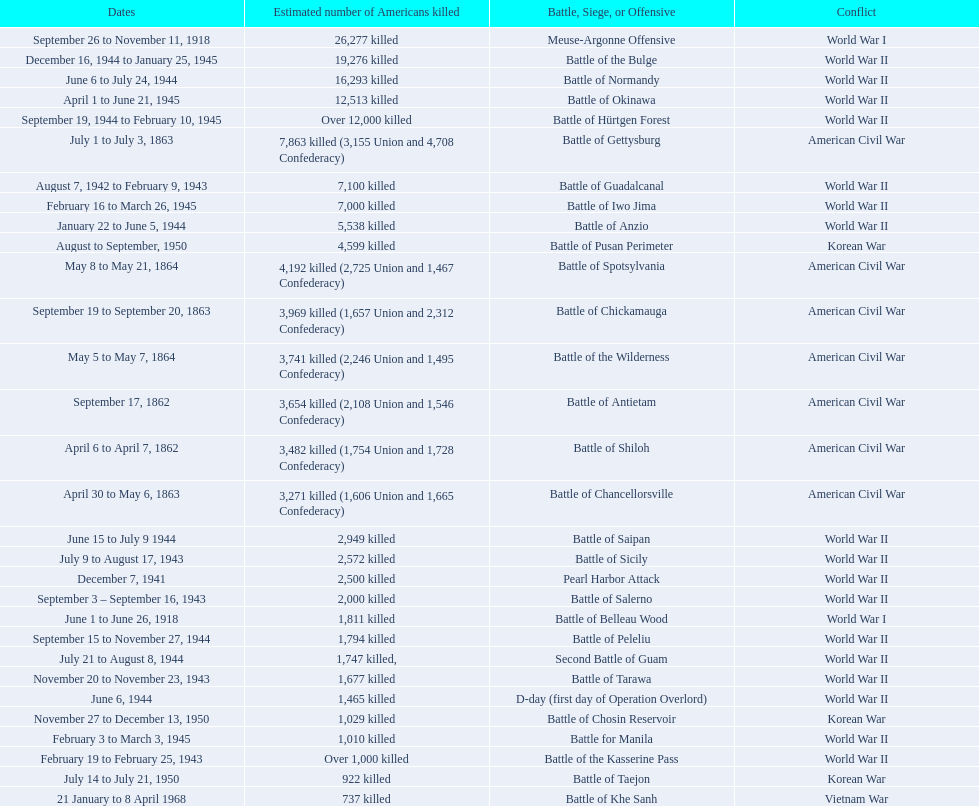How many battles resulted between 3,000 and 4,200 estimated americans killed? 6. Write the full table. {'header': ['Dates', 'Estimated number of Americans killed', 'Battle, Siege, or Offensive', 'Conflict'], 'rows': [['September 26 to November 11, 1918', '26,277 killed', 'Meuse-Argonne Offensive', 'World War I'], ['December 16, 1944 to January 25, 1945', '19,276 killed', 'Battle of the Bulge', 'World War II'], ['June 6 to July 24, 1944', '16,293 killed', 'Battle of Normandy', 'World War II'], ['April 1 to June 21, 1945', '12,513 killed', 'Battle of Okinawa', 'World War II'], ['September 19, 1944 to February 10, 1945', 'Over 12,000 killed', 'Battle of Hürtgen Forest', 'World War II'], ['July 1 to July 3, 1863', '7,863 killed (3,155 Union and 4,708 Confederacy)', 'Battle of Gettysburg', 'American Civil War'], ['August 7, 1942 to February 9, 1943', '7,100 killed', 'Battle of Guadalcanal', 'World War II'], ['February 16 to March 26, 1945', '7,000 killed', 'Battle of Iwo Jima', 'World War II'], ['January 22 to June 5, 1944', '5,538 killed', 'Battle of Anzio', 'World War II'], ['August to September, 1950', '4,599 killed', 'Battle of Pusan Perimeter', 'Korean War'], ['May 8 to May 21, 1864', '4,192 killed (2,725 Union and 1,467 Confederacy)', 'Battle of Spotsylvania', 'American Civil War'], ['September 19 to September 20, 1863', '3,969 killed (1,657 Union and 2,312 Confederacy)', 'Battle of Chickamauga', 'American Civil War'], ['May 5 to May 7, 1864', '3,741 killed (2,246 Union and 1,495 Confederacy)', 'Battle of the Wilderness', 'American Civil War'], ['September 17, 1862', '3,654 killed (2,108 Union and 1,546 Confederacy)', 'Battle of Antietam', 'American Civil War'], ['April 6 to April 7, 1862', '3,482 killed (1,754 Union and 1,728 Confederacy)', 'Battle of Shiloh', 'American Civil War'], ['April 30 to May 6, 1863', '3,271 killed (1,606 Union and 1,665 Confederacy)', 'Battle of Chancellorsville', 'American Civil War'], ['June 15 to July 9 1944', '2,949 killed', 'Battle of Saipan', 'World War II'], ['July 9 to August 17, 1943', '2,572 killed', 'Battle of Sicily', 'World War II'], ['December 7, 1941', '2,500 killed', 'Pearl Harbor Attack', 'World War II'], ['September 3 – September 16, 1943', '2,000 killed', 'Battle of Salerno', 'World War II'], ['June 1 to June 26, 1918', '1,811 killed', 'Battle of Belleau Wood', 'World War I'], ['September 15 to November 27, 1944', '1,794 killed', 'Battle of Peleliu', 'World War II'], ['July 21 to August 8, 1944', '1,747 killed,', 'Second Battle of Guam', 'World War II'], ['November 20 to November 23, 1943', '1,677 killed', 'Battle of Tarawa', 'World War II'], ['June 6, 1944', '1,465 killed', 'D-day (first day of Operation Overlord)', 'World War II'], ['November 27 to December 13, 1950', '1,029 killed', 'Battle of Chosin Reservoir', 'Korean War'], ['February 3 to March 3, 1945', '1,010 killed', 'Battle for Manila', 'World War II'], ['February 19 to February 25, 1943', 'Over 1,000 killed', 'Battle of the Kasserine Pass', 'World War II'], ['July 14 to July 21, 1950', '922 killed', 'Battle of Taejon', 'Korean War'], ['21 January to 8 April 1968', '737 killed', 'Battle of Khe Sanh', 'Vietnam War']]} 